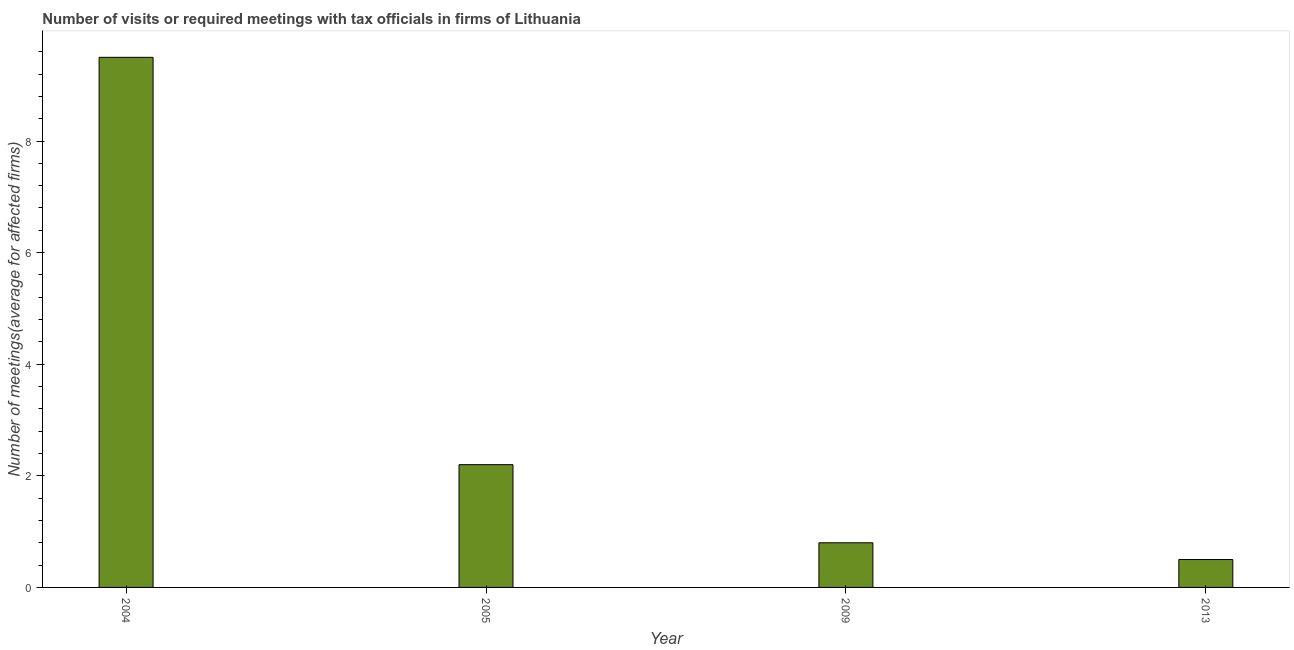Does the graph contain grids?
Your answer should be very brief. No. What is the title of the graph?
Your answer should be compact. Number of visits or required meetings with tax officials in firms of Lithuania. What is the label or title of the Y-axis?
Give a very brief answer. Number of meetings(average for affected firms). What is the number of required meetings with tax officials in 2013?
Make the answer very short. 0.5. In which year was the number of required meetings with tax officials maximum?
Provide a short and direct response. 2004. What is the difference between the number of required meetings with tax officials in 2009 and 2013?
Your answer should be compact. 0.3. What is the average number of required meetings with tax officials per year?
Offer a very short reply. 3.25. What is the median number of required meetings with tax officials?
Offer a terse response. 1.5. Do a majority of the years between 2009 and 2005 (inclusive) have number of required meetings with tax officials greater than 9.2 ?
Give a very brief answer. No. What is the ratio of the number of required meetings with tax officials in 2004 to that in 2005?
Make the answer very short. 4.32. Is the number of required meetings with tax officials in 2004 less than that in 2013?
Ensure brevity in your answer.  No. Is the difference between the number of required meetings with tax officials in 2005 and 2009 greater than the difference between any two years?
Your answer should be compact. No. What is the difference between the highest and the second highest number of required meetings with tax officials?
Provide a short and direct response. 7.3. Is the sum of the number of required meetings with tax officials in 2004 and 2009 greater than the maximum number of required meetings with tax officials across all years?
Your response must be concise. Yes. How many bars are there?
Provide a short and direct response. 4. How many years are there in the graph?
Keep it short and to the point. 4. What is the difference between two consecutive major ticks on the Y-axis?
Offer a terse response. 2. What is the Number of meetings(average for affected firms) in 2004?
Your response must be concise. 9.5. What is the Number of meetings(average for affected firms) of 2005?
Give a very brief answer. 2.2. What is the Number of meetings(average for affected firms) in 2009?
Your answer should be compact. 0.8. What is the difference between the Number of meetings(average for affected firms) in 2004 and 2009?
Your response must be concise. 8.7. What is the difference between the Number of meetings(average for affected firms) in 2005 and 2009?
Your answer should be very brief. 1.4. What is the difference between the Number of meetings(average for affected firms) in 2005 and 2013?
Make the answer very short. 1.7. What is the difference between the Number of meetings(average for affected firms) in 2009 and 2013?
Your answer should be very brief. 0.3. What is the ratio of the Number of meetings(average for affected firms) in 2004 to that in 2005?
Offer a terse response. 4.32. What is the ratio of the Number of meetings(average for affected firms) in 2004 to that in 2009?
Provide a short and direct response. 11.88. What is the ratio of the Number of meetings(average for affected firms) in 2004 to that in 2013?
Ensure brevity in your answer.  19. What is the ratio of the Number of meetings(average for affected firms) in 2005 to that in 2009?
Make the answer very short. 2.75. What is the ratio of the Number of meetings(average for affected firms) in 2009 to that in 2013?
Give a very brief answer. 1.6. 